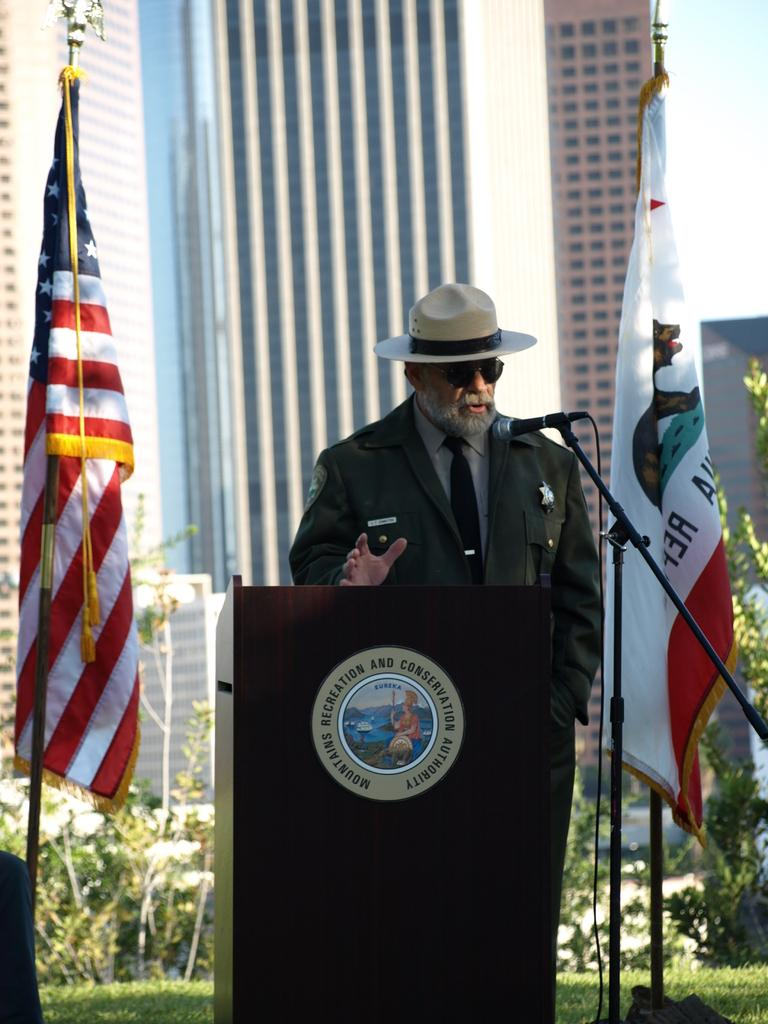What is the main subject of the image? There is a person in the image. Can you describe the person's attire? The person is wearing a hat. What is the person's posture in the image? The person is standing. What object is in front of the person? There is a microphone in front of the person. What is the wooden stand used for in the image? The wooden stand is likely used to support the microphone. What can be seen in the background of the image? There are two flags, plants, and buildings in the background. What type of brick is being used to build the person's hair in the image? There is no brick or hair visible in the image; the person is wearing a hat. 